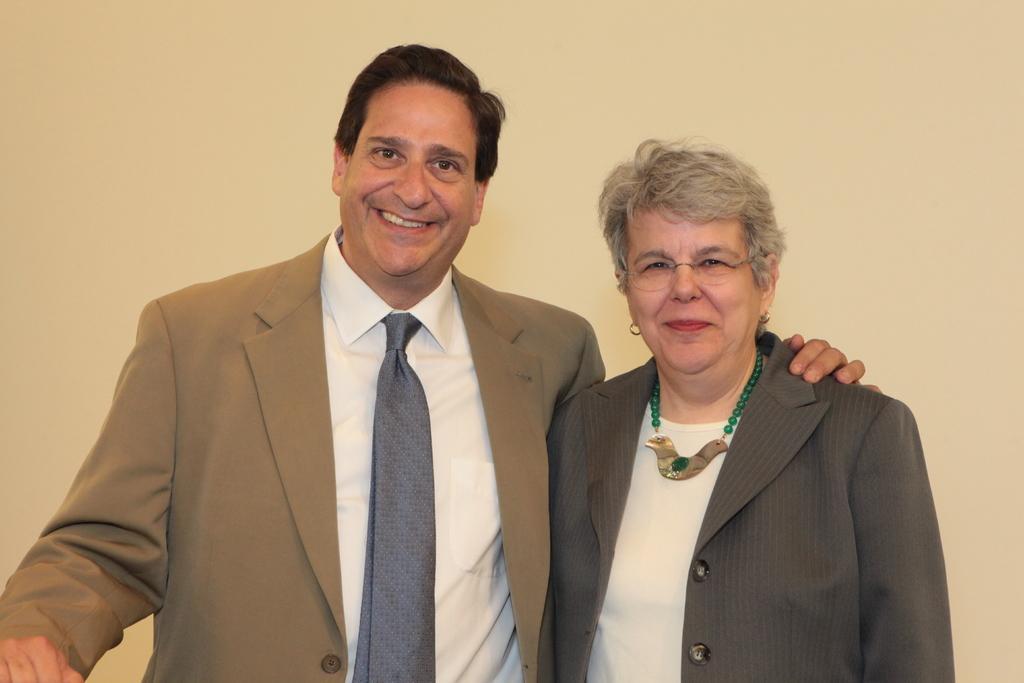In one or two sentences, can you explain what this image depicts? In this picture I can see there are two people standing here and they are wearing blazers and smiling. The backdrop is cream in color. 